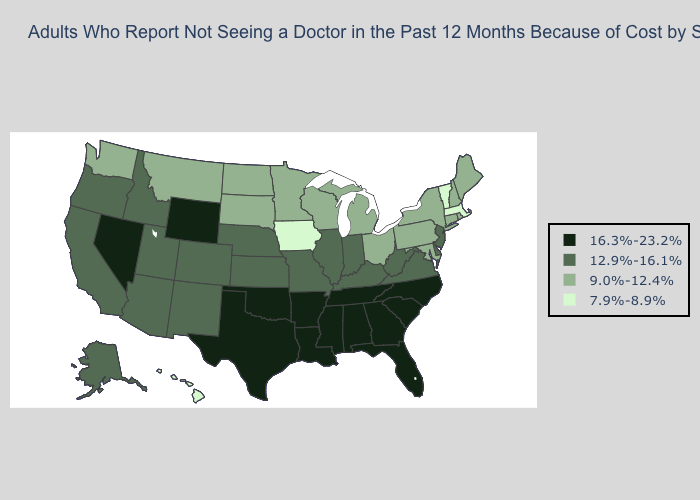Name the states that have a value in the range 12.9%-16.1%?
Concise answer only. Alaska, Arizona, California, Colorado, Delaware, Idaho, Illinois, Indiana, Kansas, Kentucky, Missouri, Nebraska, New Jersey, New Mexico, Oregon, Utah, Virginia, West Virginia. Which states have the lowest value in the USA?
Keep it brief. Hawaii, Iowa, Massachusetts, Vermont. How many symbols are there in the legend?
Answer briefly. 4. Name the states that have a value in the range 16.3%-23.2%?
Quick response, please. Alabama, Arkansas, Florida, Georgia, Louisiana, Mississippi, Nevada, North Carolina, Oklahoma, South Carolina, Tennessee, Texas, Wyoming. Name the states that have a value in the range 9.0%-12.4%?
Keep it brief. Connecticut, Maine, Maryland, Michigan, Minnesota, Montana, New Hampshire, New York, North Dakota, Ohio, Pennsylvania, Rhode Island, South Dakota, Washington, Wisconsin. Does Pennsylvania have the same value as Alaska?
Give a very brief answer. No. What is the lowest value in the South?
Short answer required. 9.0%-12.4%. What is the value of New Hampshire?
Answer briefly. 9.0%-12.4%. Does Maryland have the lowest value in the South?
Short answer required. Yes. Name the states that have a value in the range 16.3%-23.2%?
Be succinct. Alabama, Arkansas, Florida, Georgia, Louisiana, Mississippi, Nevada, North Carolina, Oklahoma, South Carolina, Tennessee, Texas, Wyoming. Is the legend a continuous bar?
Answer briefly. No. Among the states that border Idaho , which have the highest value?
Concise answer only. Nevada, Wyoming. Name the states that have a value in the range 9.0%-12.4%?
Write a very short answer. Connecticut, Maine, Maryland, Michigan, Minnesota, Montana, New Hampshire, New York, North Dakota, Ohio, Pennsylvania, Rhode Island, South Dakota, Washington, Wisconsin. Is the legend a continuous bar?
Quick response, please. No. 